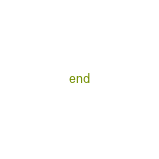<code> <loc_0><loc_0><loc_500><loc_500><_Elixir_>end
</code> 